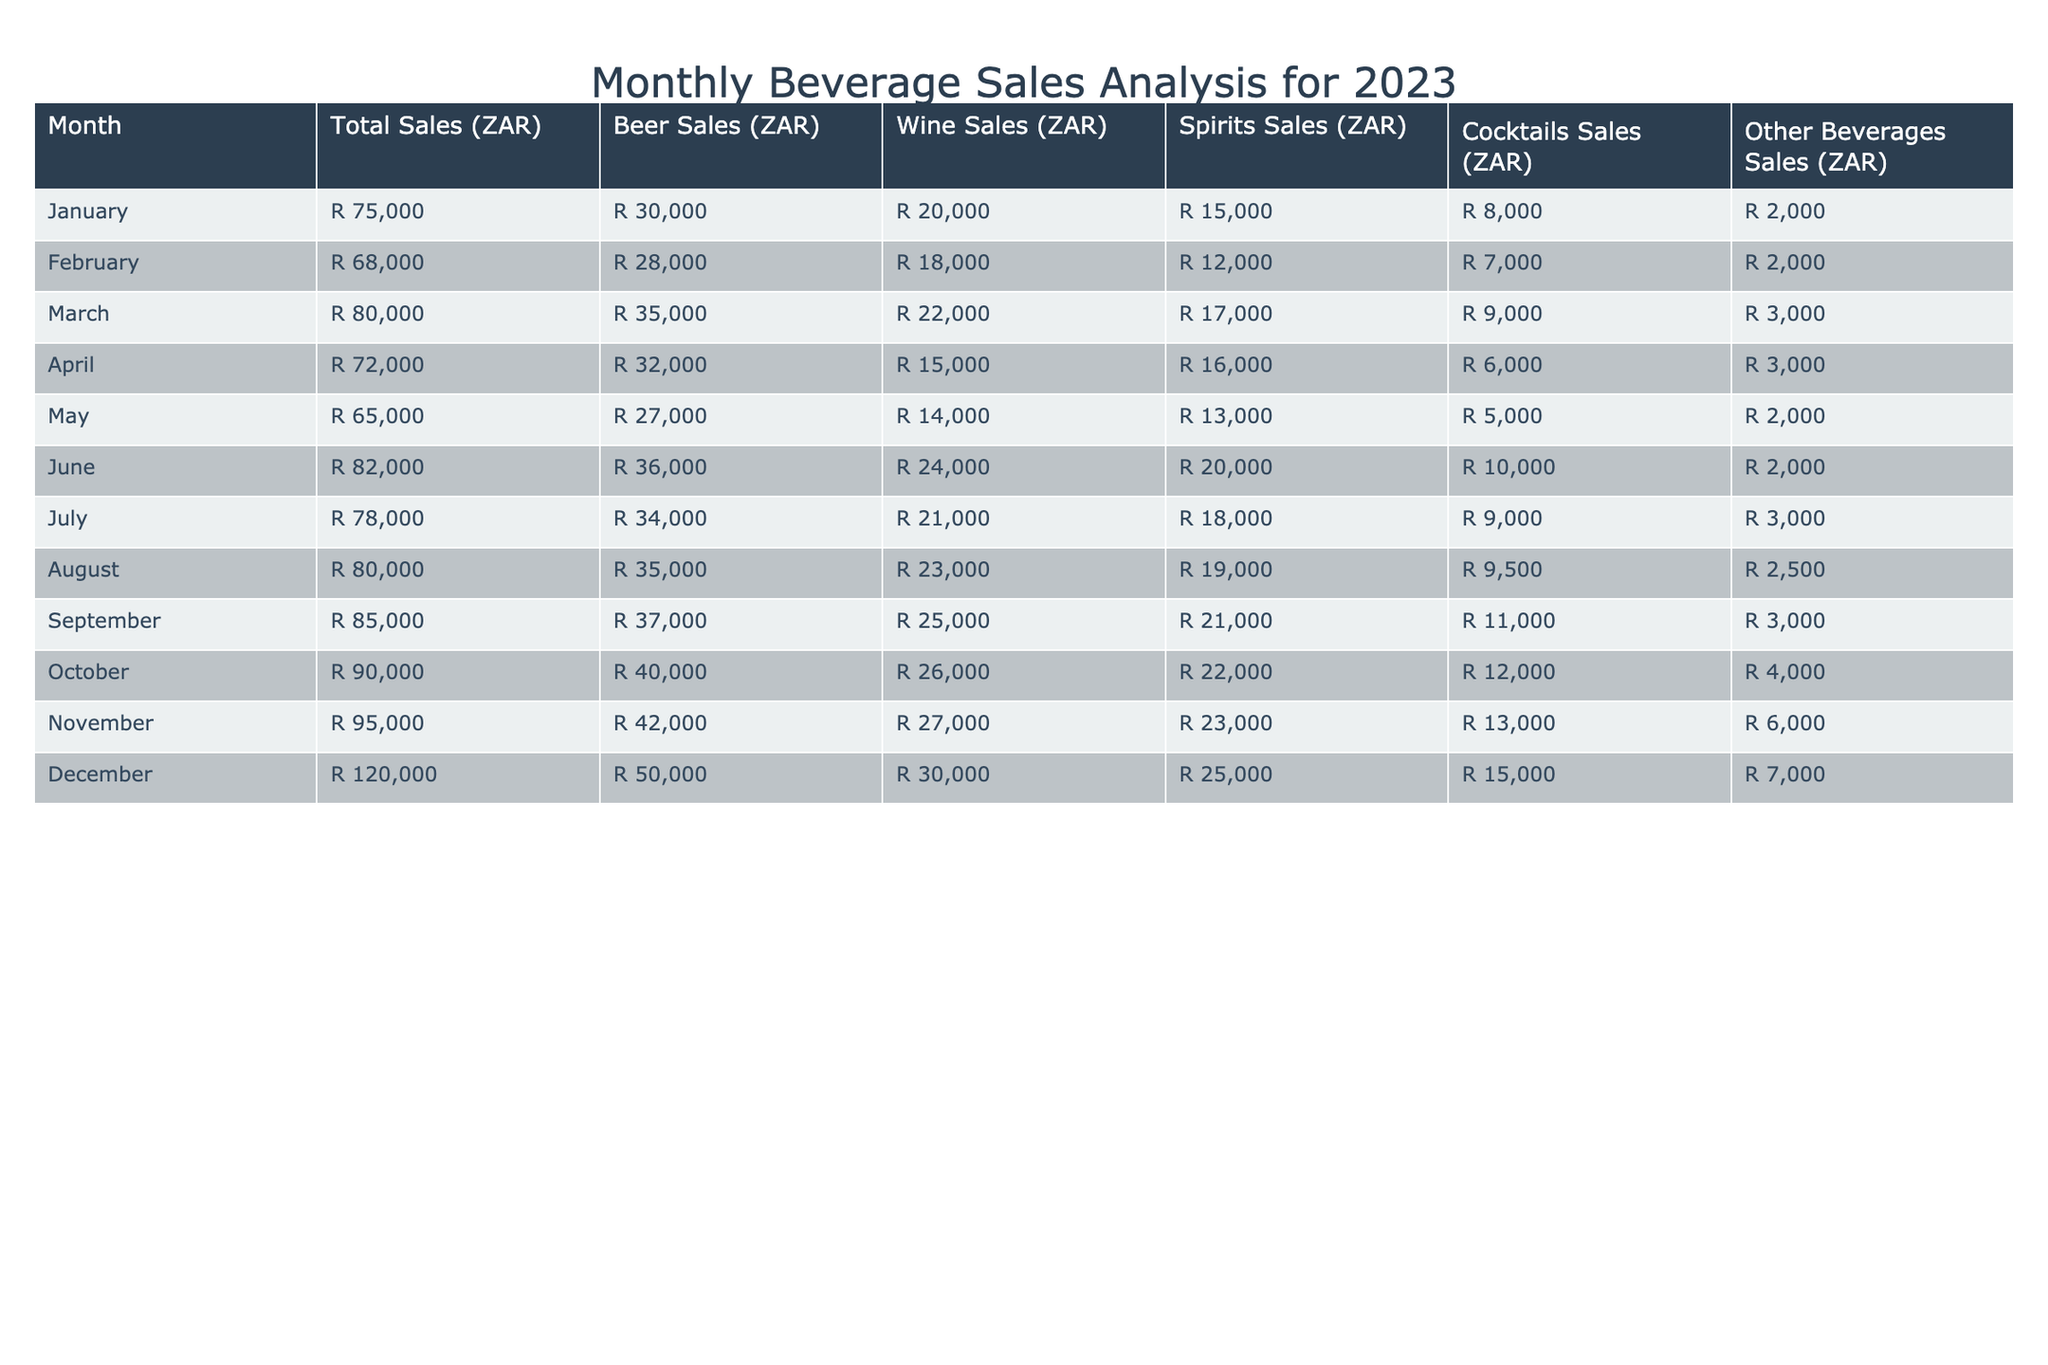What was the total beer sales in October? The table shows that in October, the total beer sales were listed under the "Beer Sales (ZAR)" column in the row for October, which indicates a value of R 40,000.
Answer: R 40,000 Which month had the highest total sales? By looking at the "Total Sales (ZAR)" column, December has the highest value listed at R 120,000 compared to other months.
Answer: R 120,000 What is the average wine sales over the year? Summing the wine sales for all months: (20,000 + 18,000 + 22,000 + 15,000 + 14,000 + 24,000 + 21,000 + 23,000 + 25,000 + 26,000 + 27,000 + 30,000) = R  297,000. Dividing by 12 months gives an average of R 24,750.
Answer: R 24,750 In which month did spirits sales exceed R 20,000? Looking through the "Spirits Sales (ZAR)" column, the months where spirits sales exceed R 20,000 are June (R 20,000), July (R 18,000), August (R 19,000), September (R 21,000), October (R 22,000), November (R 23,000), and December (R 25,000).
Answer: June, September, October, November, December Did any month have higher cocktails sales than R 10,000? By checking the "Cocktails Sales (ZAR)" column, only June (R 10,000), July (R 9,000), August (R 9,500), September (R 11,000), October (R 12,000), November (R 13,000), and December (R 15,000) had values over R 10,000.
Answer: Yes Which month saw the lowest sales in other beverages? Referring to the "Other Beverages Sales (ZAR)" column, May shows the least sales at R 2,000, in comparison to other months where sales were higher.
Answer: May What was the total sales for the first half of the year (January to June)? To find this, we add the total sales from January to June: \( 75,000 + 68,000 + 80,000 + 72,000 + 65,000 + 82,000 = R 442,000 \) total for six months.
Answer: R 442,000 Was there a month where total sales fell below R 70,000? Scanning the "Total Sales (ZAR)" column reveals that February (R 68,000) and May (R 65,000) both fell below R 70,000.
Answer: Yes, February and May Which type of beverage had the highest sales in December? The December row in the "Beer Sales (ZAR)", "Wine Sales (ZAR)", "Spirits Sales (ZAR)", "Cocktails Sales (ZAR)", and "Other Beverages Sales (ZAR)" shows that beer sales were R 50,000, wine sales were R 30,000, spirits were R 25,000, cocktails were R 15,000, and other beverages were R 7,000. Thus, beer had the highest sales.
Answer: Beer 